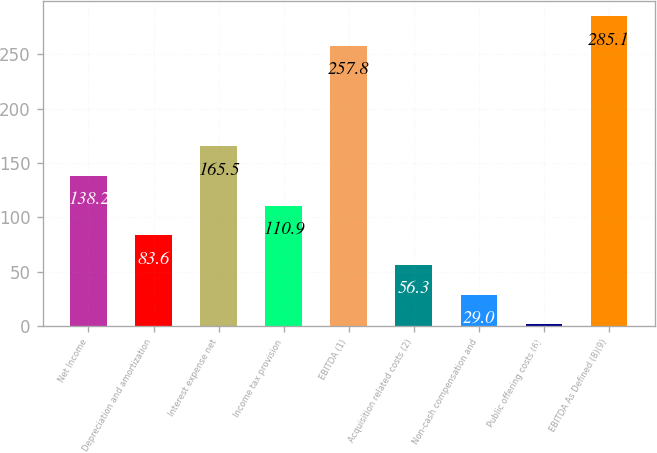Convert chart to OTSL. <chart><loc_0><loc_0><loc_500><loc_500><bar_chart><fcel>Net Income<fcel>Depreciation and amortization<fcel>Interest expense net<fcel>Income tax provision<fcel>EBITDA (1)<fcel>Acquisition related costs (2)<fcel>Non-cash compensation and<fcel>Public offering costs (6)<fcel>EBITDA As Defined (8)(9)<nl><fcel>138.2<fcel>83.6<fcel>165.5<fcel>110.9<fcel>257.8<fcel>56.3<fcel>29<fcel>1.7<fcel>285.1<nl></chart> 